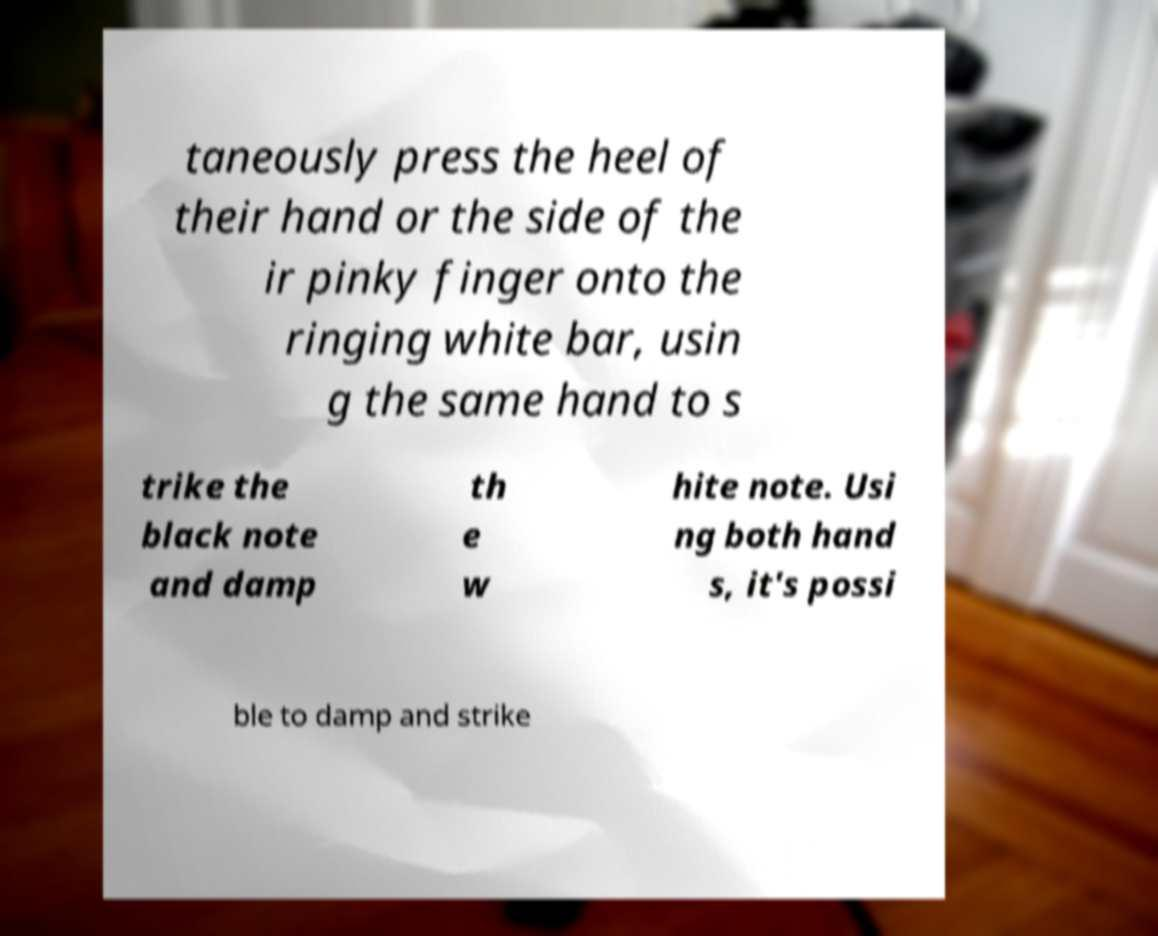For documentation purposes, I need the text within this image transcribed. Could you provide that? taneously press the heel of their hand or the side of the ir pinky finger onto the ringing white bar, usin g the same hand to s trike the black note and damp th e w hite note. Usi ng both hand s, it's possi ble to damp and strike 